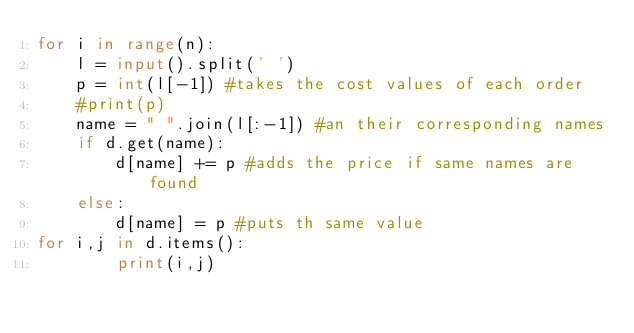<code> <loc_0><loc_0><loc_500><loc_500><_Python_>for i in range(n):
    l = input().split(' ')
    p = int(l[-1]) #takes the cost values of each order
    #print(p)
    name = " ".join(l[:-1]) #an their corresponding names
    if d.get(name):
        d[name] += p #adds the price if same names are found
    else:
        d[name] = p #puts th same value
for i,j in d.items():
        print(i,j)</code> 